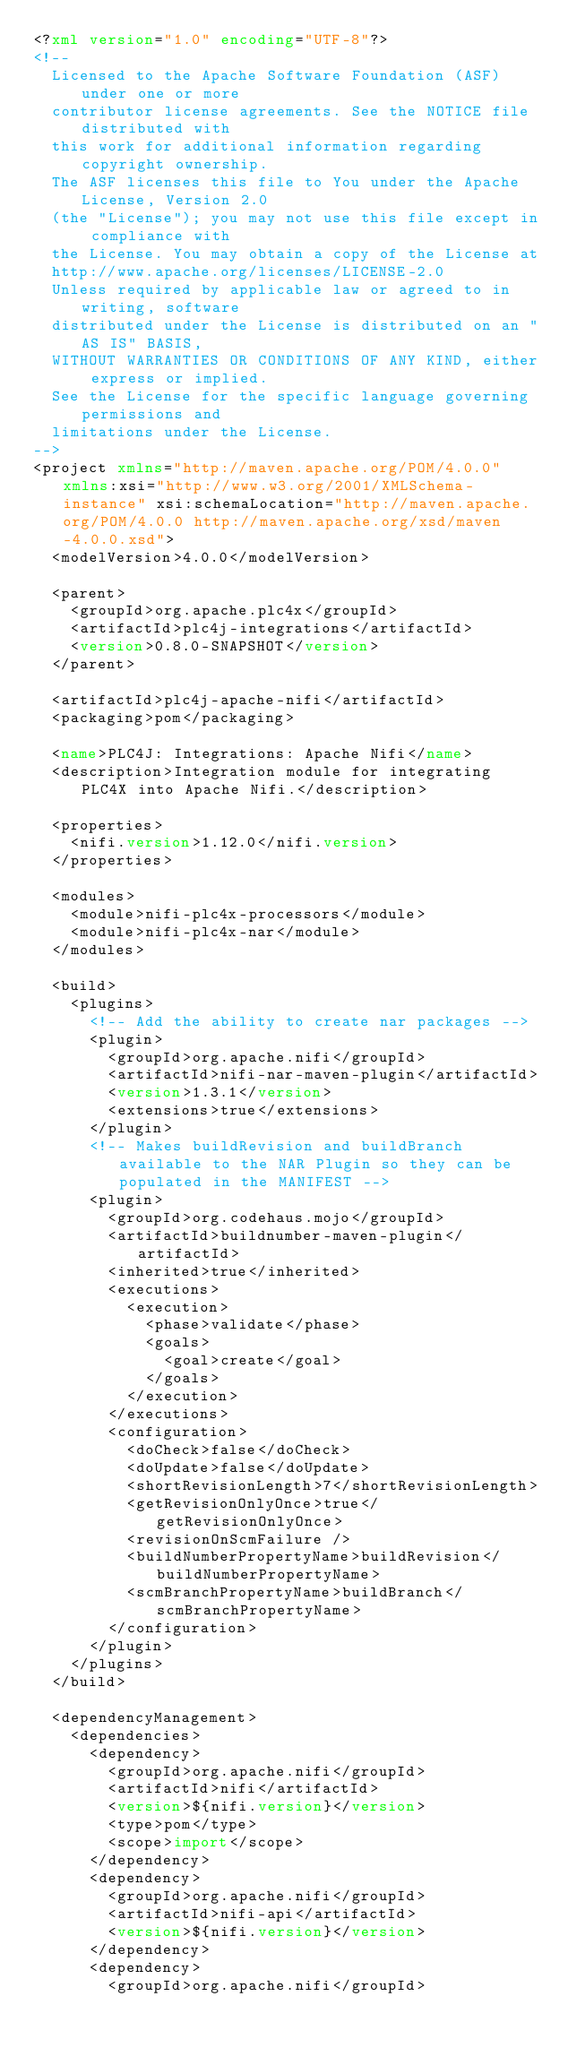<code> <loc_0><loc_0><loc_500><loc_500><_XML_><?xml version="1.0" encoding="UTF-8"?>
<!--
  Licensed to the Apache Software Foundation (ASF) under one or more
  contributor license agreements. See the NOTICE file distributed with
  this work for additional information regarding copyright ownership.
  The ASF licenses this file to You under the Apache License, Version 2.0
  (the "License"); you may not use this file except in compliance with
  the License. You may obtain a copy of the License at
  http://www.apache.org/licenses/LICENSE-2.0
  Unless required by applicable law or agreed to in writing, software
  distributed under the License is distributed on an "AS IS" BASIS,
  WITHOUT WARRANTIES OR CONDITIONS OF ANY KIND, either express or implied.
  See the License for the specific language governing permissions and
  limitations under the License.
-->
<project xmlns="http://maven.apache.org/POM/4.0.0" xmlns:xsi="http://www.w3.org/2001/XMLSchema-instance" xsi:schemaLocation="http://maven.apache.org/POM/4.0.0 http://maven.apache.org/xsd/maven-4.0.0.xsd">
  <modelVersion>4.0.0</modelVersion>

  <parent>
    <groupId>org.apache.plc4x</groupId>
    <artifactId>plc4j-integrations</artifactId>
    <version>0.8.0-SNAPSHOT</version>
  </parent>

  <artifactId>plc4j-apache-nifi</artifactId>
  <packaging>pom</packaging>

  <name>PLC4J: Integrations: Apache Nifi</name>
  <description>Integration module for integrating PLC4X into Apache Nifi.</description>

  <properties>
    <nifi.version>1.12.0</nifi.version>
  </properties>

  <modules>
    <module>nifi-plc4x-processors</module>
    <module>nifi-plc4x-nar</module>
  </modules>

  <build>
    <plugins>
      <!-- Add the ability to create nar packages -->
      <plugin>
        <groupId>org.apache.nifi</groupId>
        <artifactId>nifi-nar-maven-plugin</artifactId>
        <version>1.3.1</version>
        <extensions>true</extensions>
      </plugin>
      <!-- Makes buildRevision and buildBranch available to the NAR Plugin so they can be populated in the MANIFEST -->
      <plugin>
        <groupId>org.codehaus.mojo</groupId>
        <artifactId>buildnumber-maven-plugin</artifactId>
        <inherited>true</inherited>
        <executions>
          <execution>
            <phase>validate</phase>
            <goals>
              <goal>create</goal>
            </goals>
          </execution>
        </executions>
        <configuration>
          <doCheck>false</doCheck>
          <doUpdate>false</doUpdate>
          <shortRevisionLength>7</shortRevisionLength>
          <getRevisionOnlyOnce>true</getRevisionOnlyOnce>
          <revisionOnScmFailure />
          <buildNumberPropertyName>buildRevision</buildNumberPropertyName>
          <scmBranchPropertyName>buildBranch</scmBranchPropertyName>
        </configuration>
      </plugin>
    </plugins>
  </build>

  <dependencyManagement>
    <dependencies>
      <dependency>
        <groupId>org.apache.nifi</groupId>
        <artifactId>nifi</artifactId>
        <version>${nifi.version}</version>
        <type>pom</type>
        <scope>import</scope>
      </dependency>
      <dependency>
        <groupId>org.apache.nifi</groupId>
        <artifactId>nifi-api</artifactId>
        <version>${nifi.version}</version>
      </dependency>
      <dependency>
        <groupId>org.apache.nifi</groupId></code> 